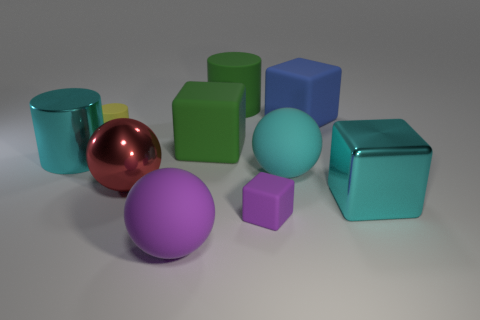There is a ball that is the same color as the large metal block; what is its size?
Provide a short and direct response. Large. Is the number of yellow matte cylinders that are right of the red thing greater than the number of red objects?
Ensure brevity in your answer.  No. How many spheres are either large purple matte objects or tiny purple things?
Your answer should be compact. 1. What shape is the metallic object that is both on the left side of the purple ball and to the right of the large shiny cylinder?
Ensure brevity in your answer.  Sphere. Are there the same number of matte cylinders that are on the right side of the green rubber cylinder and purple rubber objects right of the big metallic cube?
Your response must be concise. Yes. What number of things are either large rubber spheres or cyan metallic objects?
Your answer should be compact. 4. The rubber cylinder that is the same size as the red metal ball is what color?
Keep it short and to the point. Green. How many things are either large matte spheres that are on the right side of the small purple matte thing or big spheres in front of the cyan ball?
Your answer should be compact. 3. Are there the same number of purple matte things left of the yellow rubber cylinder and green objects?
Give a very brief answer. No. There is a shiny object that is to the right of the large red metal ball; is its size the same as the shiny thing to the left of the yellow matte cylinder?
Ensure brevity in your answer.  Yes. 